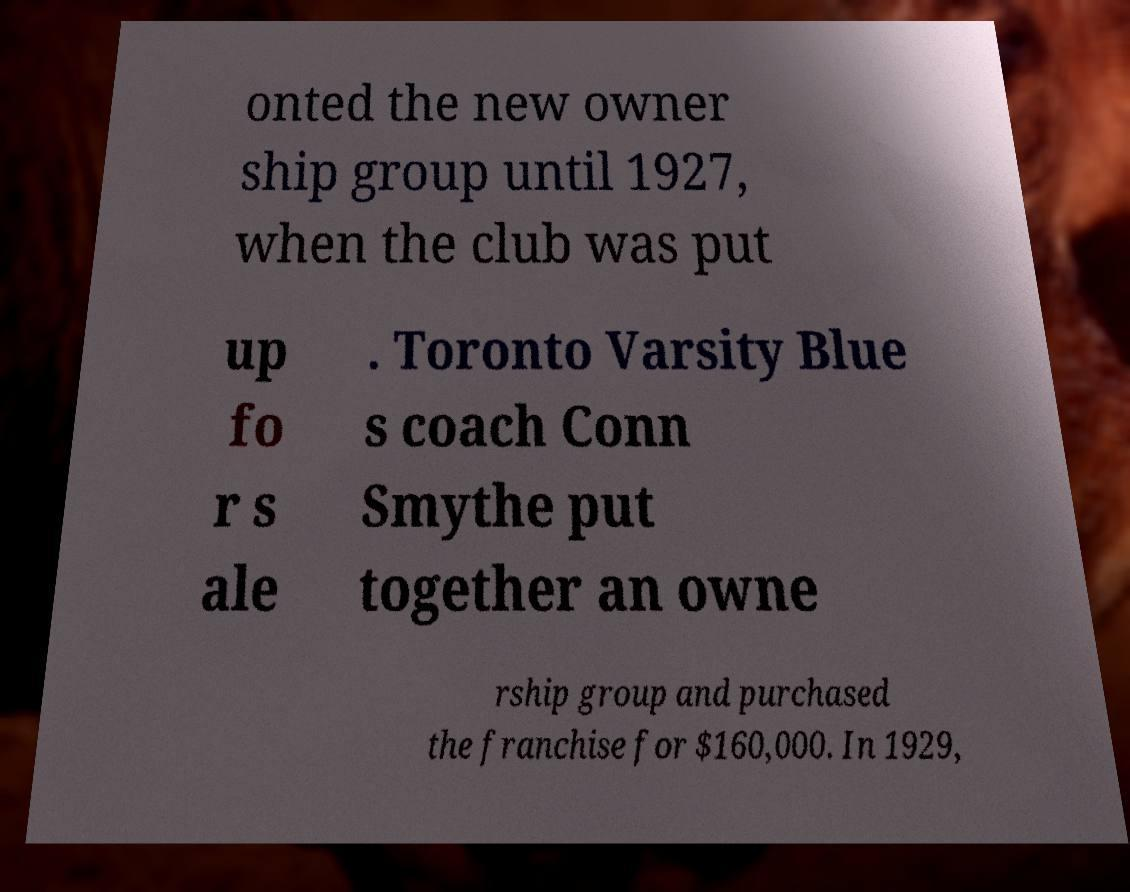Can you accurately transcribe the text from the provided image for me? onted the new owner ship group until 1927, when the club was put up fo r s ale . Toronto Varsity Blue s coach Conn Smythe put together an owne rship group and purchased the franchise for $160,000. In 1929, 